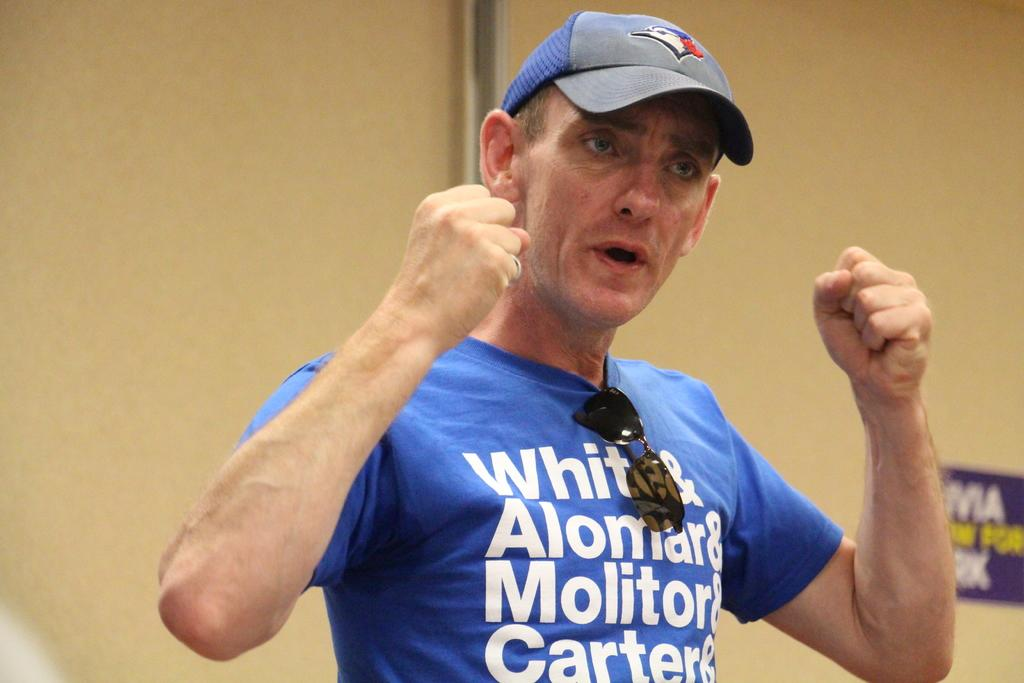<image>
Relay a brief, clear account of the picture shown. A man wears a blue shirt that says White&Alomar&Molitor&Carter& 